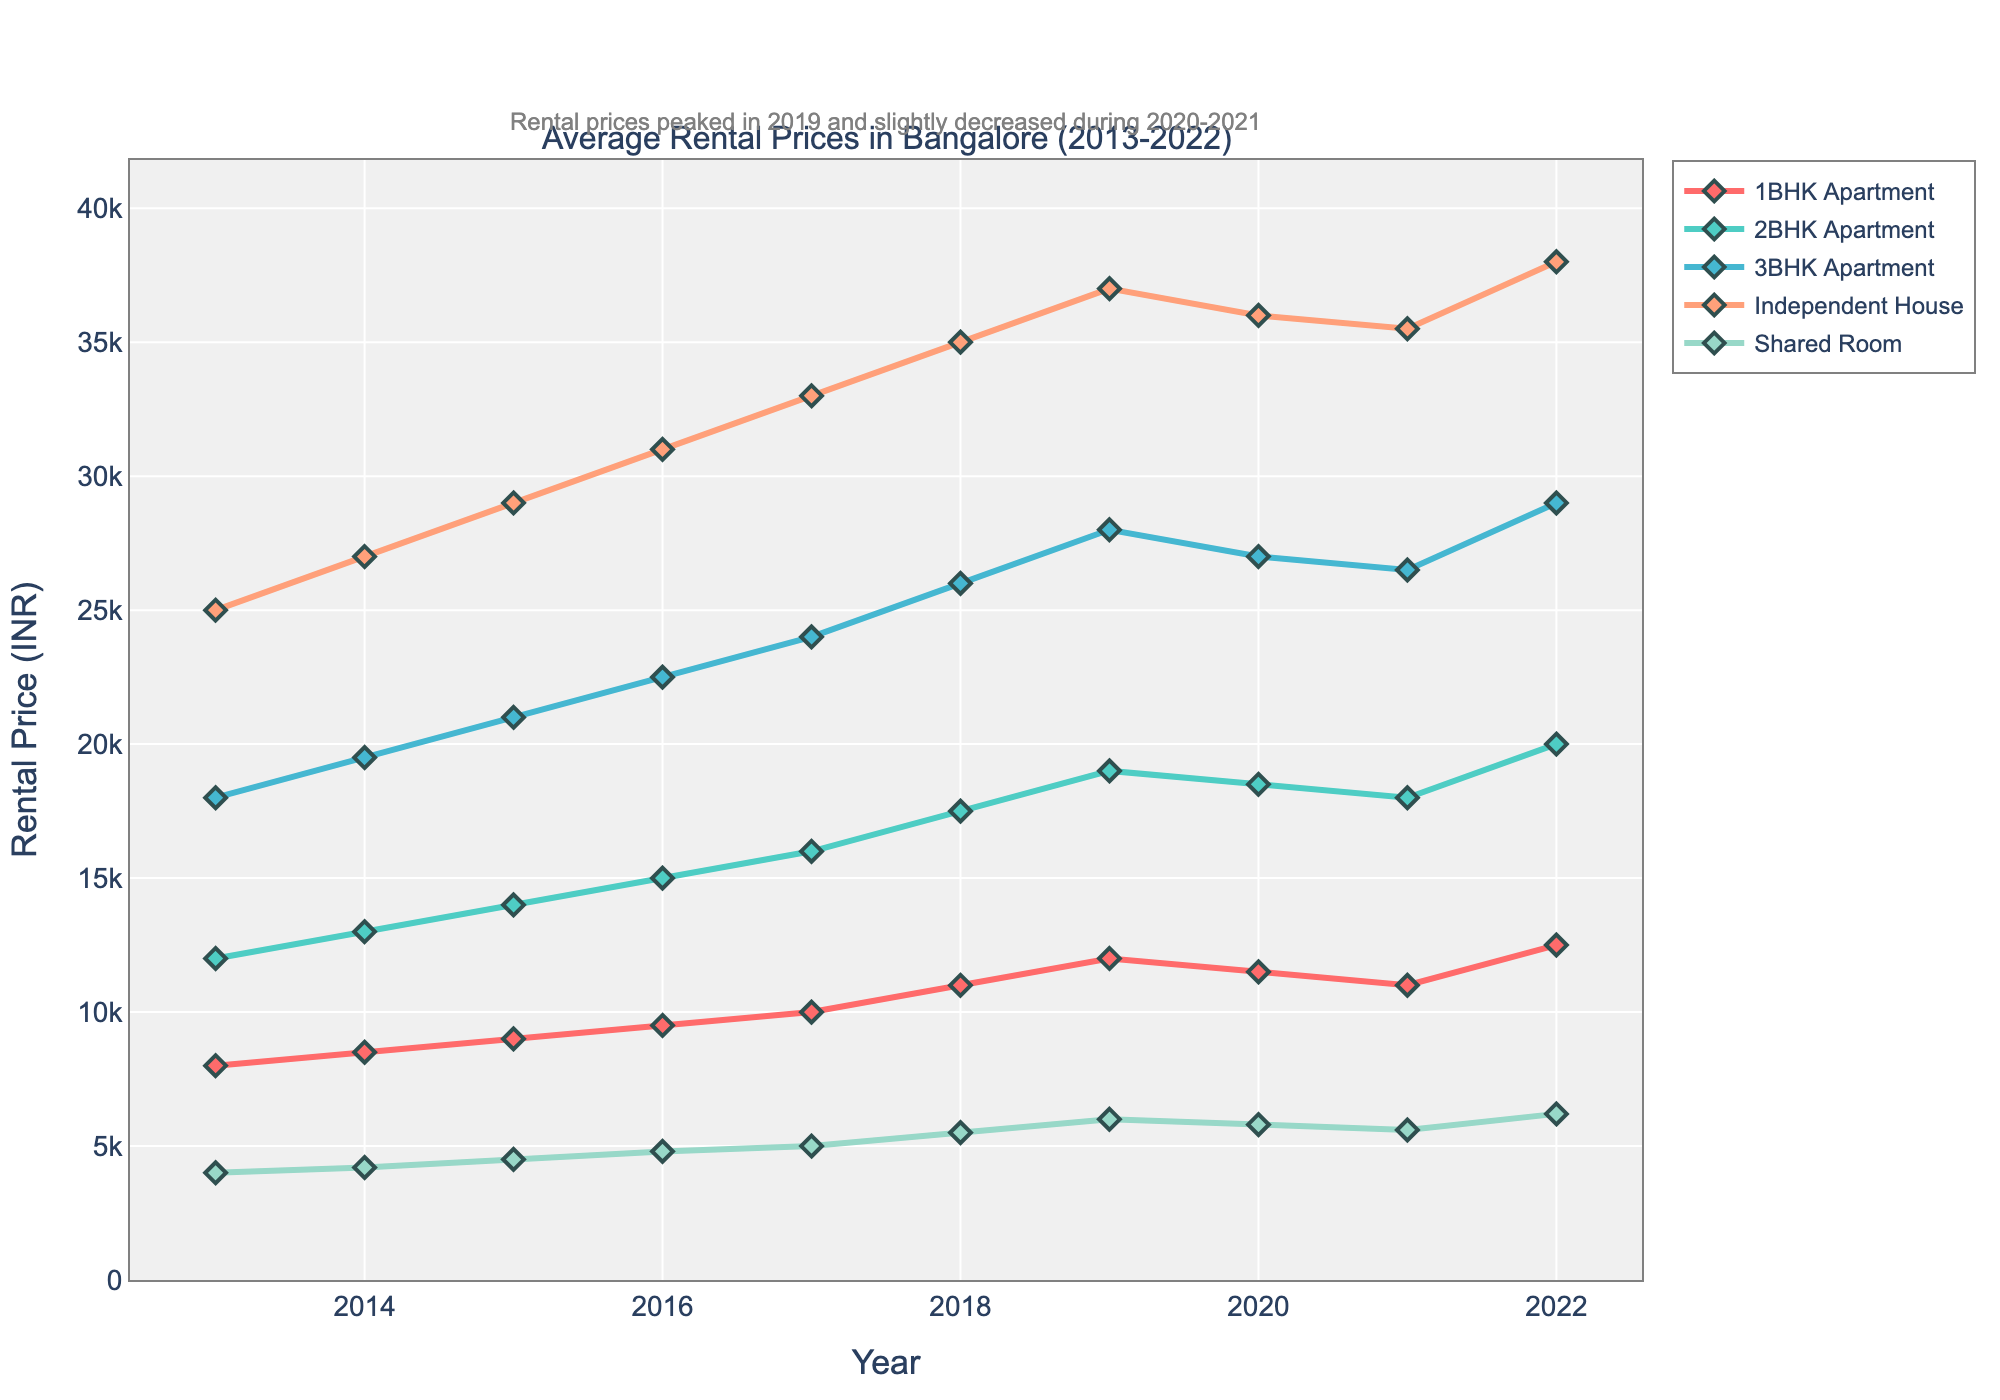What type of accommodation experienced the highest increase in rental prices from 2013 to 2022? To determine the highest increase, we subtract the 2013 value from the 2022 value for each accommodation type. Independent House went from 25000 to 38000 (an increase of 13000), Shared Room went from 4000 to 6200 (an increase of 2200), 1BHK Apartment went from 8000 to 12500 (an increase of 4500), 2BHK Apartment went from 12000 to 20000 (an increase of 8000), and 3BHK Apartment went from 18000 to 29000 (an increase of 11000). Independent House has the highest increase of 13000.
Answer: Independent House Which year shows the highest rental price for 3BHK Apartments within the chart? The rental prices for 3BHK Apartments are: 2013: 18000, 2014: 19500, 2015: 21000, 2016: 22500, 2017: 24000, 2018: 26000, 2019: 28000, 2020: 27000, 2021: 26500, 2022: 29000. The highest price, 29000, is in 2022.
Answer: 2022 How do the rental prices for 1BHK Apartments and Shared Rooms compare in 2020? From the chart, the rental price for 1BHK Apartments in 2020 is 11500, while the rental price for Shared Rooms is 5800. Comparing them, 1BHK Apartments are significantly more expensive.
Answer: 1BHK Apartments are more expensive Identify the year where the rental price for a 2BHK Apartment first exceeded 15000. The rental prices for 2BHK Apartments before and after 15000 are: 2013: 12000, 2014: 13000, 2015: 14000, 2016: 15000, 2017: 16000. The year it first exceeded 15000 is 2017.
Answer: 2017 What is the difference in rental prices between a 1BHK and a 3BHK Apartment in 2013? The rental prices in 2013 for a 1BHK Apartment is 8000 and for a 3BHK Apartment is 18000. The difference is 18000 - 8000 = 10000.
Answer: 10000 Did the rental prices for any type of accommodation decrease between 2019 and 2021? Checking the rental prices from 2019 to 2021: 1BHK Apartments decreased from 12000 to 11000, 2BHK Apartments decreased from 19000 to 18000, 3BHK Apartments have a slight decrease from 28000 to 26500, Independent House decreased from 37000 to 35500, Shared Rooms decreased from 6000 to 5600. All mentioned accommodations show a decrease.
Answer: Yes Which accommodation type had the most stable rental prices over the 10-year period? By observing the line trends, Shared Rooms have the most stable prices with gradual increases and less fluctuation compared to other types.
Answer: Shared Rooms Find the average rental price of a 2BHK Apartment from 2013 to 2017. Sum the values from 2013 to 2017 for 2BHK Apartments: 12000, 13000, 14000, 15000, 16000. The sum is 12000 + 13000 + 14000 + 15000 + 16000 = 70000. Divide by 5 years: 70000 / 5 = 14000.
Answer: 14000 By how much did the rental price for Independent Houses increase from 2016 to 2018? The rental price for Independent Houses in 2016 is 31000 and in 2018 it is 35000. The increase is 35000 - 31000 = 4000.
Answer: 4000 